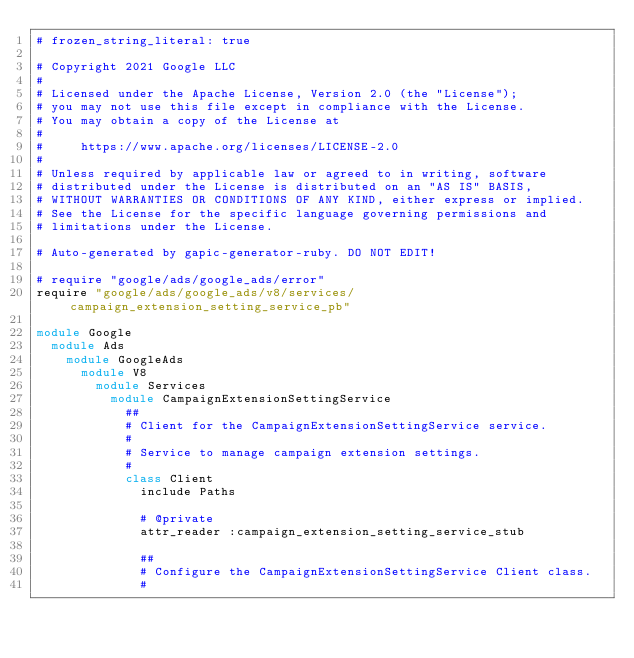Convert code to text. <code><loc_0><loc_0><loc_500><loc_500><_Ruby_># frozen_string_literal: true

# Copyright 2021 Google LLC
#
# Licensed under the Apache License, Version 2.0 (the "License");
# you may not use this file except in compliance with the License.
# You may obtain a copy of the License at
#
#     https://www.apache.org/licenses/LICENSE-2.0
#
# Unless required by applicable law or agreed to in writing, software
# distributed under the License is distributed on an "AS IS" BASIS,
# WITHOUT WARRANTIES OR CONDITIONS OF ANY KIND, either express or implied.
# See the License for the specific language governing permissions and
# limitations under the License.

# Auto-generated by gapic-generator-ruby. DO NOT EDIT!

# require "google/ads/google_ads/error"
require "google/ads/google_ads/v8/services/campaign_extension_setting_service_pb"

module Google
  module Ads
    module GoogleAds
      module V8
        module Services
          module CampaignExtensionSettingService
            ##
            # Client for the CampaignExtensionSettingService service.
            #
            # Service to manage campaign extension settings.
            #
            class Client
              include Paths

              # @private
              attr_reader :campaign_extension_setting_service_stub

              ##
              # Configure the CampaignExtensionSettingService Client class.
              #</code> 